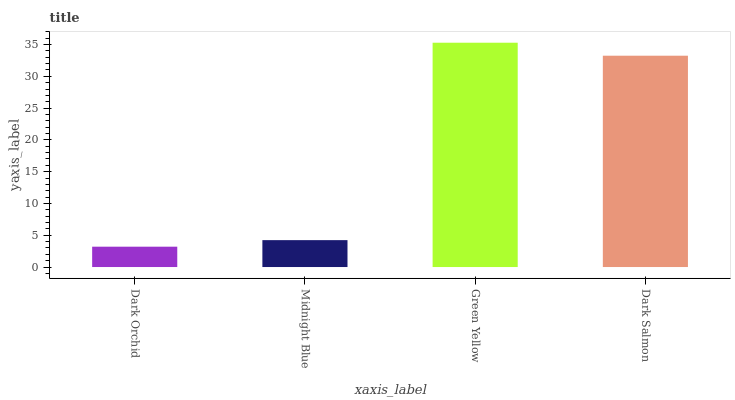Is Dark Orchid the minimum?
Answer yes or no. Yes. Is Green Yellow the maximum?
Answer yes or no. Yes. Is Midnight Blue the minimum?
Answer yes or no. No. Is Midnight Blue the maximum?
Answer yes or no. No. Is Midnight Blue greater than Dark Orchid?
Answer yes or no. Yes. Is Dark Orchid less than Midnight Blue?
Answer yes or no. Yes. Is Dark Orchid greater than Midnight Blue?
Answer yes or no. No. Is Midnight Blue less than Dark Orchid?
Answer yes or no. No. Is Dark Salmon the high median?
Answer yes or no. Yes. Is Midnight Blue the low median?
Answer yes or no. Yes. Is Green Yellow the high median?
Answer yes or no. No. Is Dark Orchid the low median?
Answer yes or no. No. 